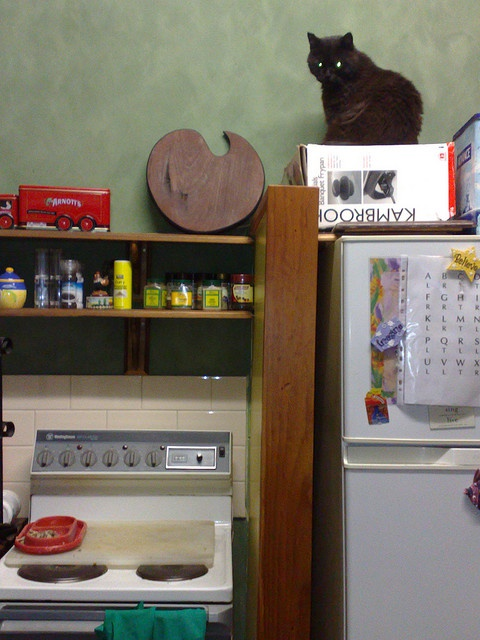Describe the objects in this image and their specific colors. I can see refrigerator in gray, darkgray, black, and lightgray tones, oven in gray, darkgray, black, and lightgray tones, and cat in gray, black, maroon, and white tones in this image. 